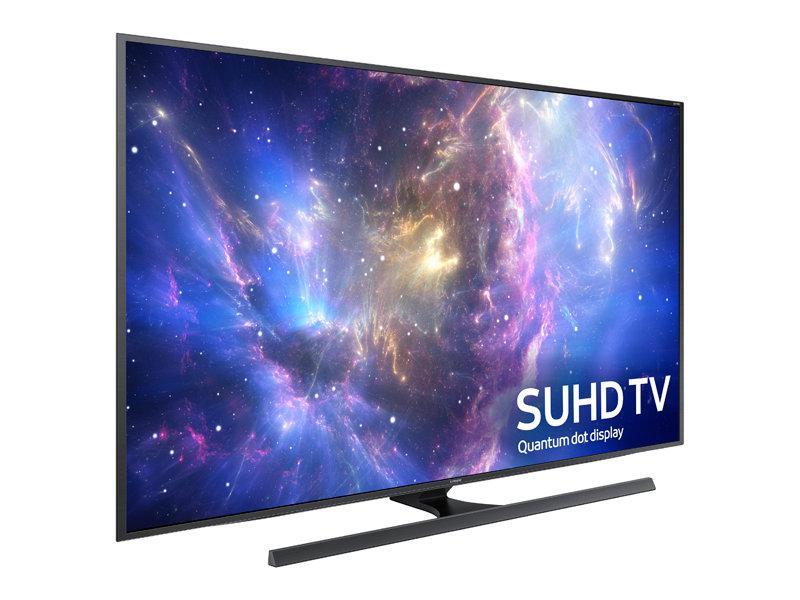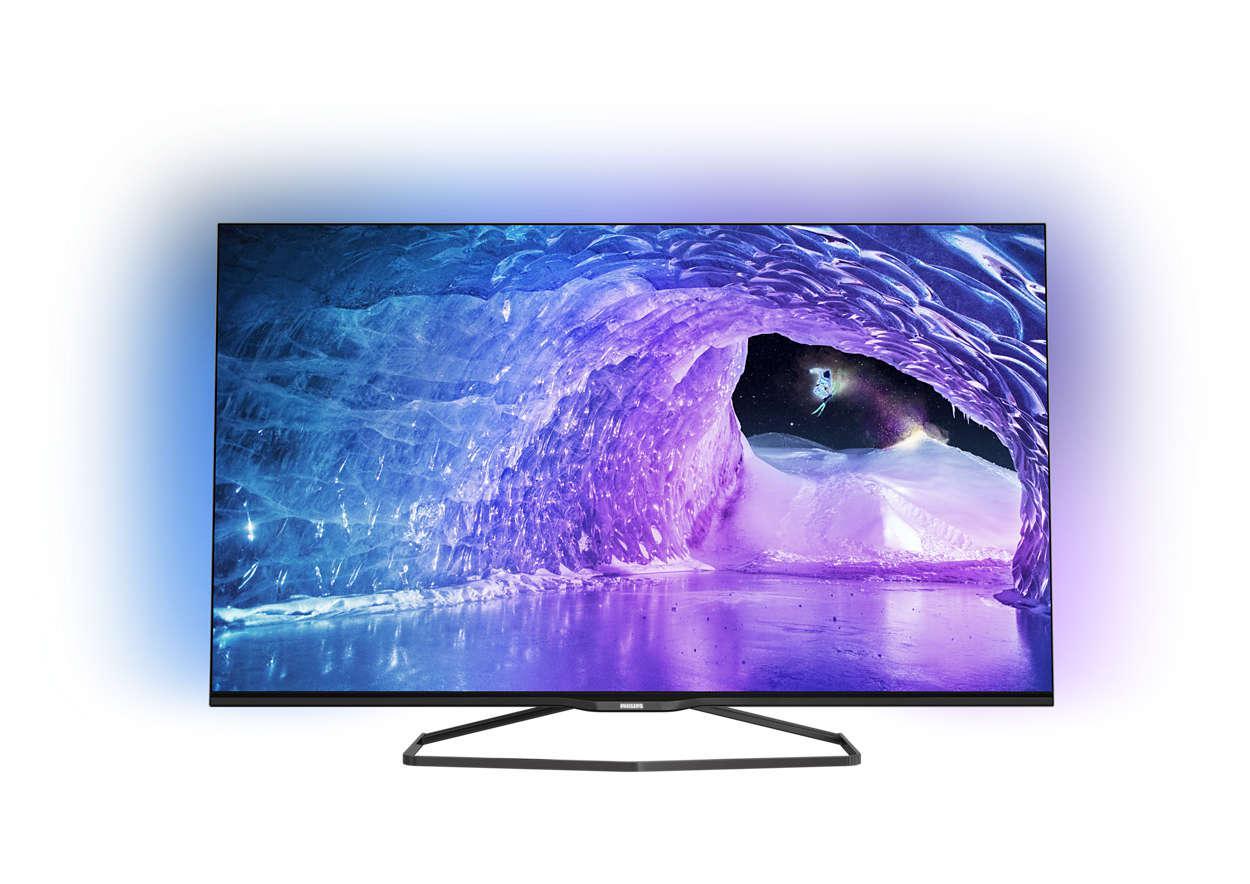The first image is the image on the left, the second image is the image on the right. Examine the images to the left and right. Is the description "One screen is flat and viewed head-on, and the other screen is curved and displayed at an angle." accurate? Answer yes or no. No. The first image is the image on the left, the second image is the image on the right. Assess this claim about the two images: "The left and right image contains the same number television with at least one curved television.". Correct or not? Answer yes or no. No. 